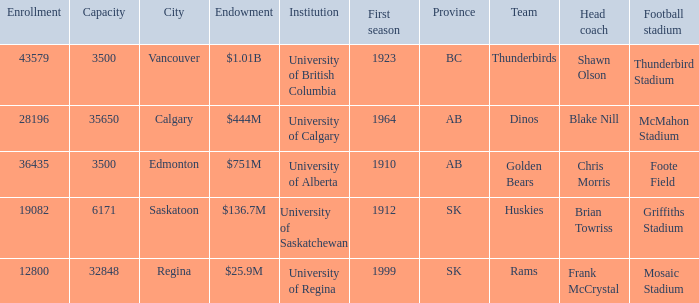What year did University of Saskatchewan have their first season? 1912.0. 